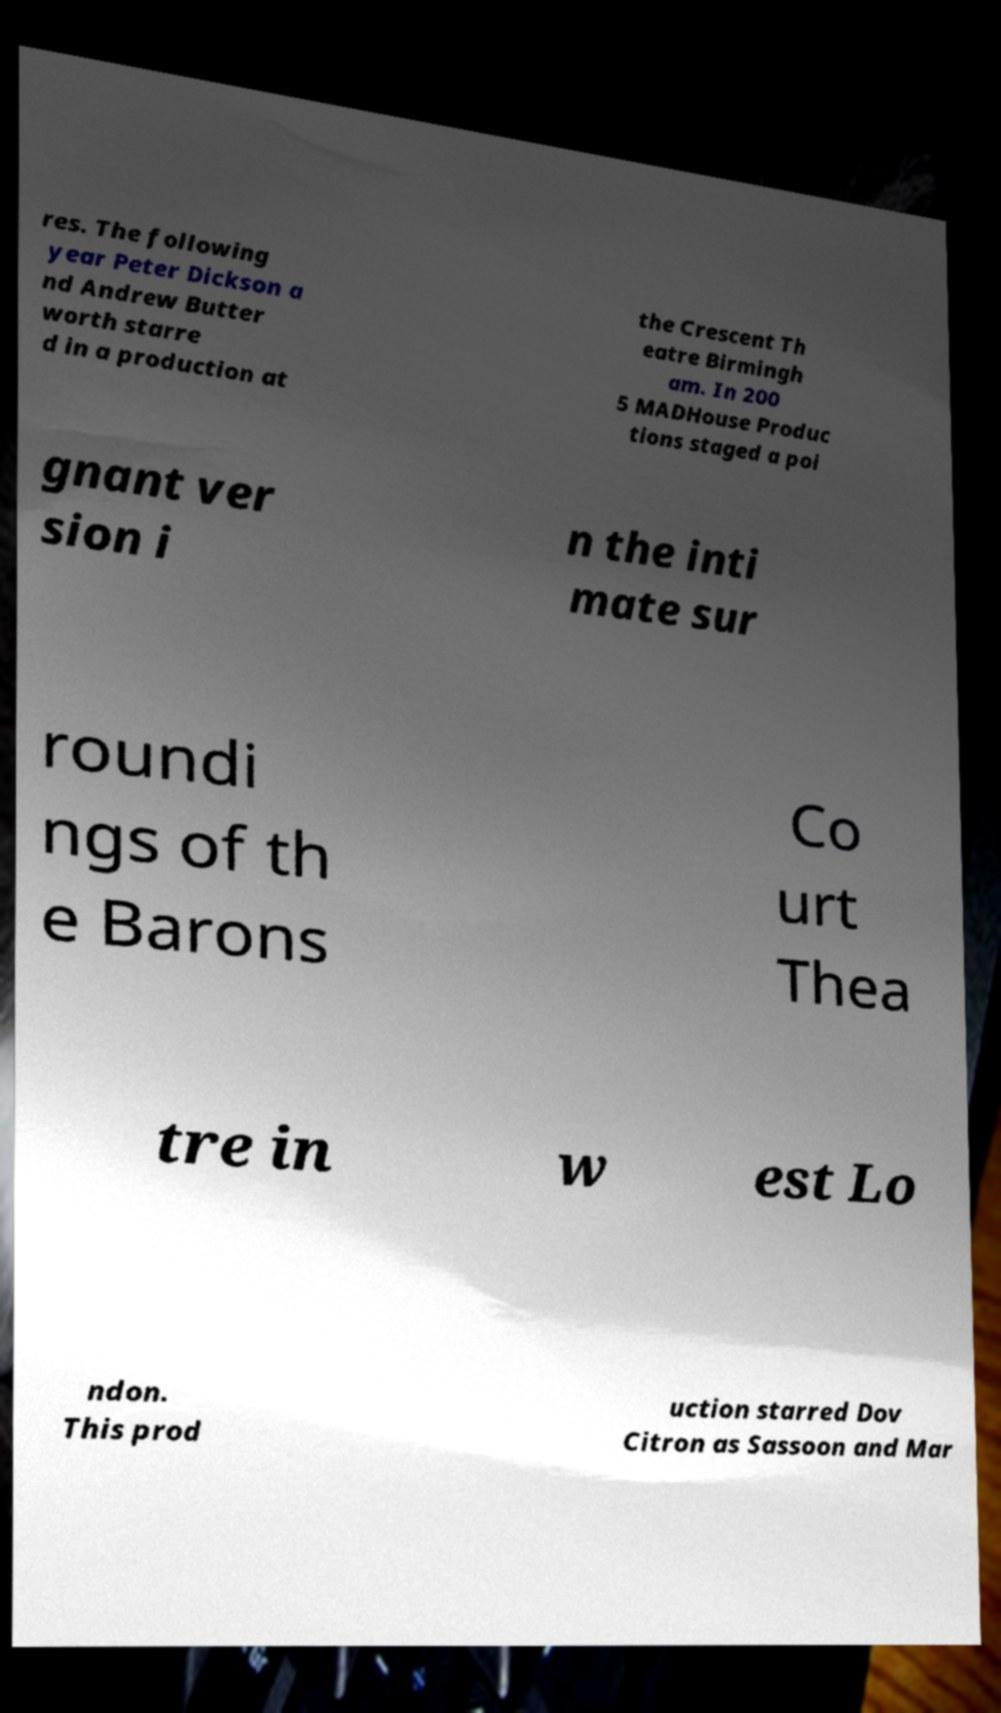Please identify and transcribe the text found in this image. res. The following year Peter Dickson a nd Andrew Butter worth starre d in a production at the Crescent Th eatre Birmingh am. In 200 5 MADHouse Produc tions staged a poi gnant ver sion i n the inti mate sur roundi ngs of th e Barons Co urt Thea tre in w est Lo ndon. This prod uction starred Dov Citron as Sassoon and Mar 